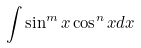Convert formula to latex. <formula><loc_0><loc_0><loc_500><loc_500>\int \sin ^ { m } x \cos ^ { n } x d x</formula> 